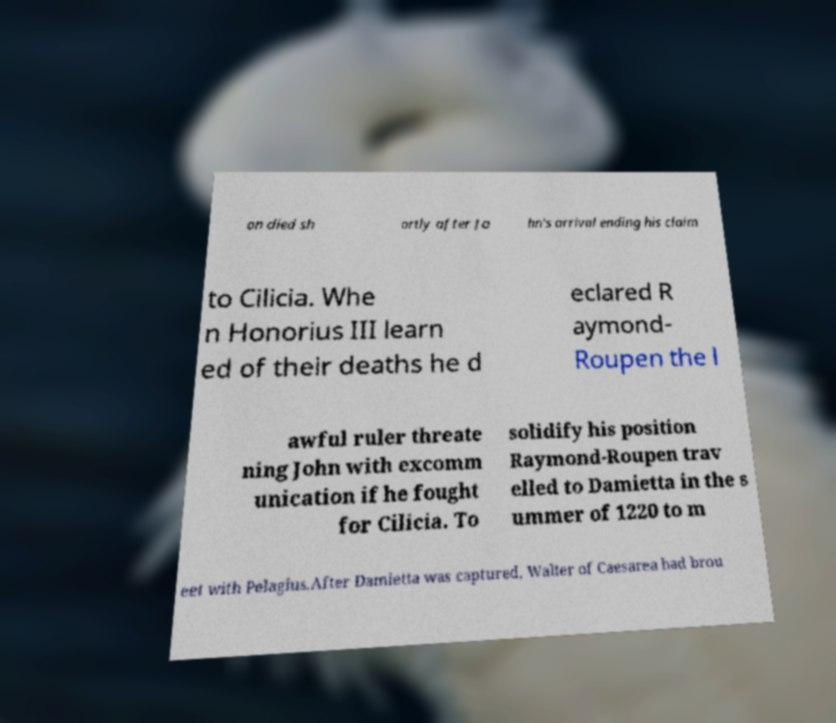What messages or text are displayed in this image? I need them in a readable, typed format. on died sh ortly after Jo hn's arrival ending his claim to Cilicia. Whe n Honorius III learn ed of their deaths he d eclared R aymond- Roupen the l awful ruler threate ning John with excomm unication if he fought for Cilicia. To solidify his position Raymond-Roupen trav elled to Damietta in the s ummer of 1220 to m eet with Pelagius.After Damietta was captured, Walter of Caesarea had brou 